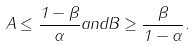<formula> <loc_0><loc_0><loc_500><loc_500>A \leq \frac { 1 - \beta } { \alpha } a n d B \geq \frac { \beta } { 1 - \alpha } .</formula> 